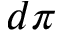<formula> <loc_0><loc_0><loc_500><loc_500>d \pi</formula> 